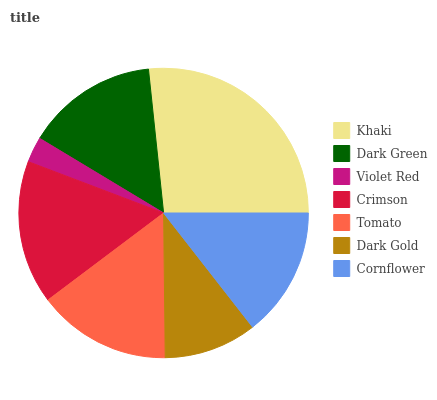Is Violet Red the minimum?
Answer yes or no. Yes. Is Khaki the maximum?
Answer yes or no. Yes. Is Dark Green the minimum?
Answer yes or no. No. Is Dark Green the maximum?
Answer yes or no. No. Is Khaki greater than Dark Green?
Answer yes or no. Yes. Is Dark Green less than Khaki?
Answer yes or no. Yes. Is Dark Green greater than Khaki?
Answer yes or no. No. Is Khaki less than Dark Green?
Answer yes or no. No. Is Dark Green the high median?
Answer yes or no. Yes. Is Dark Green the low median?
Answer yes or no. Yes. Is Khaki the high median?
Answer yes or no. No. Is Tomato the low median?
Answer yes or no. No. 